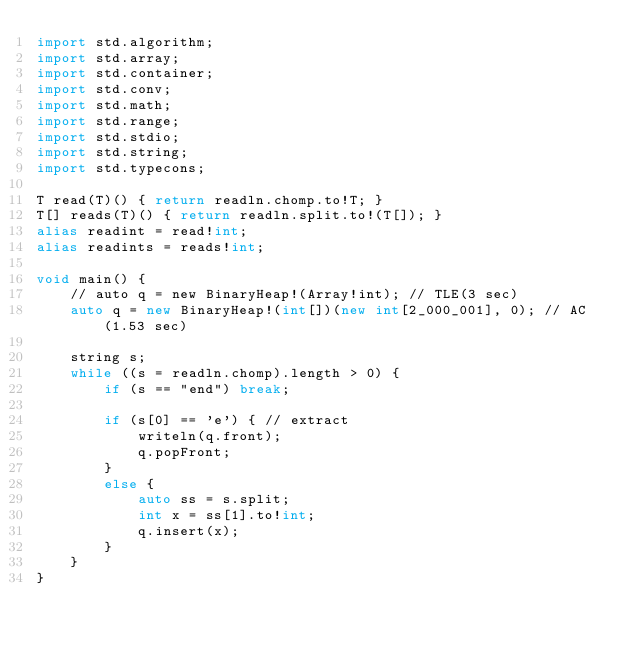<code> <loc_0><loc_0><loc_500><loc_500><_D_>import std.algorithm;
import std.array;
import std.container;
import std.conv;
import std.math;
import std.range;
import std.stdio;
import std.string;
import std.typecons;

T read(T)() { return readln.chomp.to!T; }
T[] reads(T)() { return readln.split.to!(T[]); }
alias readint = read!int;
alias readints = reads!int;

void main() {
    // auto q = new BinaryHeap!(Array!int); // TLE(3 sec)
    auto q = new BinaryHeap!(int[])(new int[2_000_001], 0); // AC(1.53 sec)

    string s;
    while ((s = readln.chomp).length > 0) {
        if (s == "end") break;

        if (s[0] == 'e') { // extract
            writeln(q.front);
            q.popFront;
        }
        else {
            auto ss = s.split;
            int x = ss[1].to!int;
            q.insert(x);
        }
    }
}

</code> 